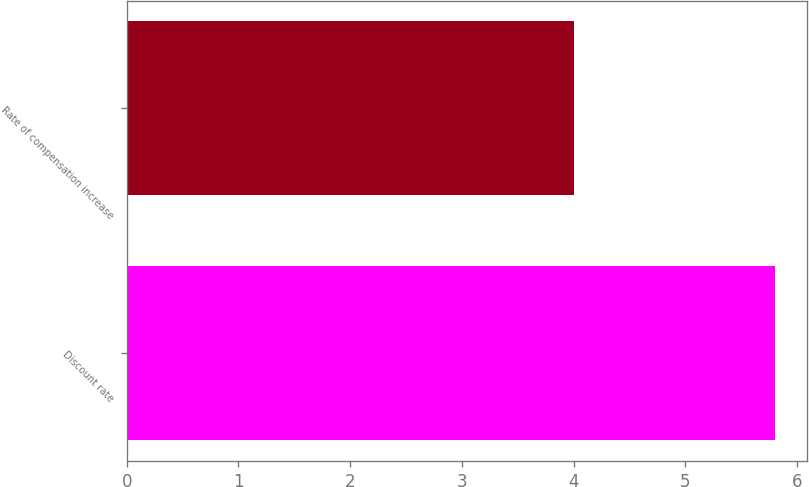<chart> <loc_0><loc_0><loc_500><loc_500><bar_chart><fcel>Discount rate<fcel>Rate of compensation increase<nl><fcel>5.8<fcel>4<nl></chart> 